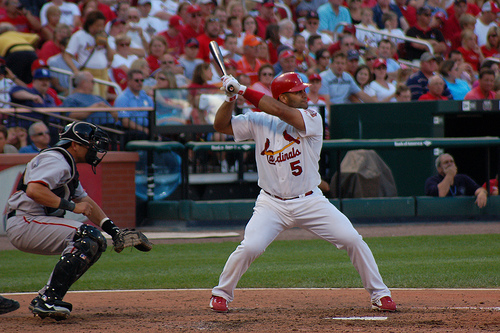How many people are swinging a bat? In the image, there is one person swinging a bat, poised mid-swing as he appears to be fully focused on the incoming baseball. 